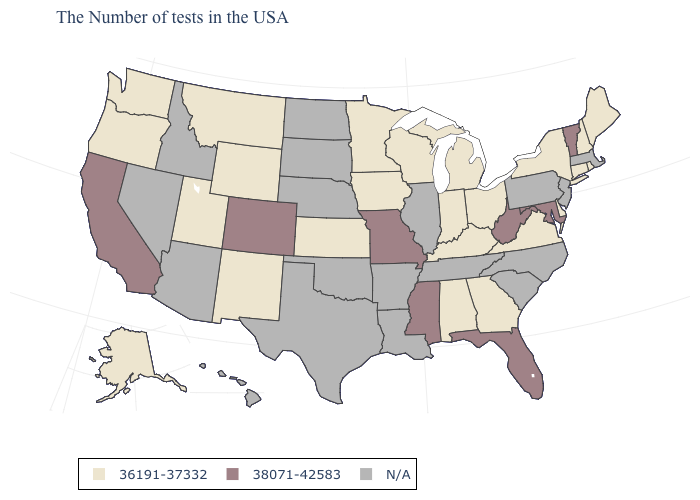Name the states that have a value in the range N/A?
Be succinct. Massachusetts, New Jersey, Pennsylvania, North Carolina, South Carolina, Tennessee, Illinois, Louisiana, Arkansas, Nebraska, Oklahoma, Texas, South Dakota, North Dakota, Arizona, Idaho, Nevada, Hawaii. Which states have the highest value in the USA?
Write a very short answer. Vermont, Maryland, West Virginia, Florida, Mississippi, Missouri, Colorado, California. What is the value of Rhode Island?
Keep it brief. 36191-37332. What is the value of Georgia?
Concise answer only. 36191-37332. Name the states that have a value in the range 36191-37332?
Write a very short answer. Maine, Rhode Island, New Hampshire, Connecticut, New York, Delaware, Virginia, Ohio, Georgia, Michigan, Kentucky, Indiana, Alabama, Wisconsin, Minnesota, Iowa, Kansas, Wyoming, New Mexico, Utah, Montana, Washington, Oregon, Alaska. Among the states that border Maine , which have the highest value?
Be succinct. New Hampshire. Which states have the highest value in the USA?
Concise answer only. Vermont, Maryland, West Virginia, Florida, Mississippi, Missouri, Colorado, California. What is the value of Georgia?
Write a very short answer. 36191-37332. Among the states that border Iowa , does Wisconsin have the lowest value?
Concise answer only. Yes. What is the value of Maine?
Give a very brief answer. 36191-37332. Among the states that border North Carolina , which have the lowest value?
Write a very short answer. Virginia, Georgia. Name the states that have a value in the range N/A?
Write a very short answer. Massachusetts, New Jersey, Pennsylvania, North Carolina, South Carolina, Tennessee, Illinois, Louisiana, Arkansas, Nebraska, Oklahoma, Texas, South Dakota, North Dakota, Arizona, Idaho, Nevada, Hawaii. Among the states that border Kentucky , which have the highest value?
Quick response, please. West Virginia, Missouri. Which states have the lowest value in the Northeast?
Short answer required. Maine, Rhode Island, New Hampshire, Connecticut, New York. 